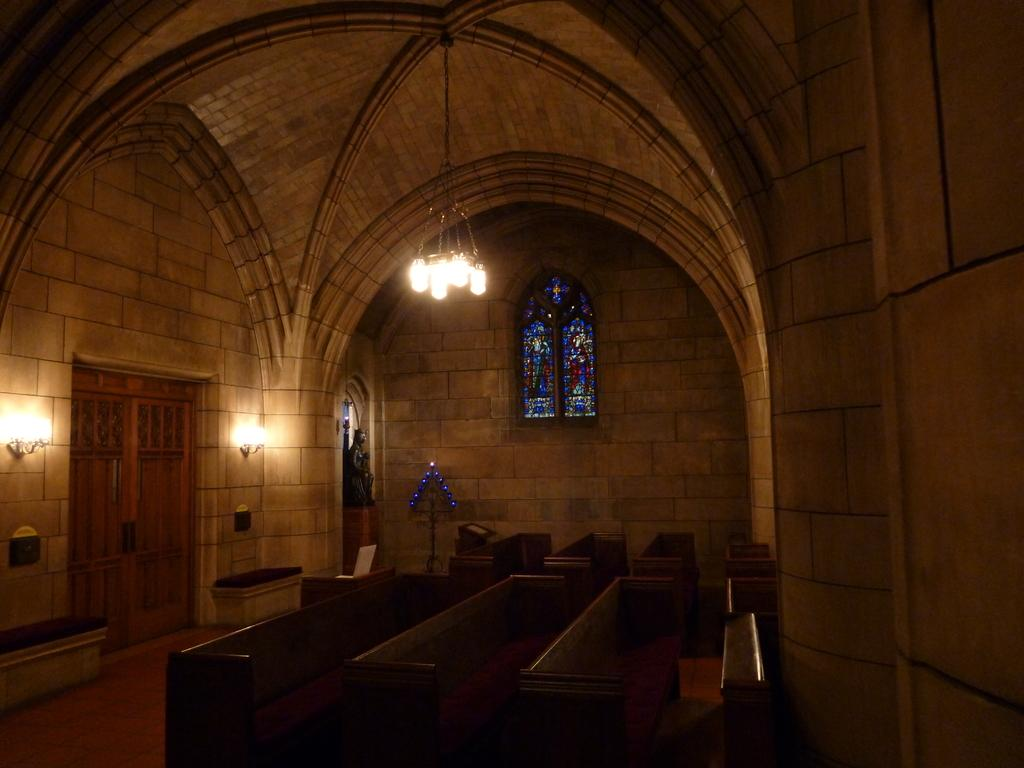What type of furniture is on the floor in the image? There are benches on the floor in the image. What can be used to enter or exit a room in the image? There are doors in the image. What provides illumination in the image? There are lights in the image. What separates the different areas in the image? There are walls in the image. What is a decorative or artistic feature in the image? There is a statue in the image. What is above the objects and people in the image? There is a ceiling in the image. What else can be seen in the image besides the mentioned elements? There are some objects in the image. What can be seen in the background of the image? There is a window visible in the background of the image. What effect does the mom have on the country in the image? There is no mention of a mom or a country in the image; the conversation focuses on the elements and objects present in the image. 